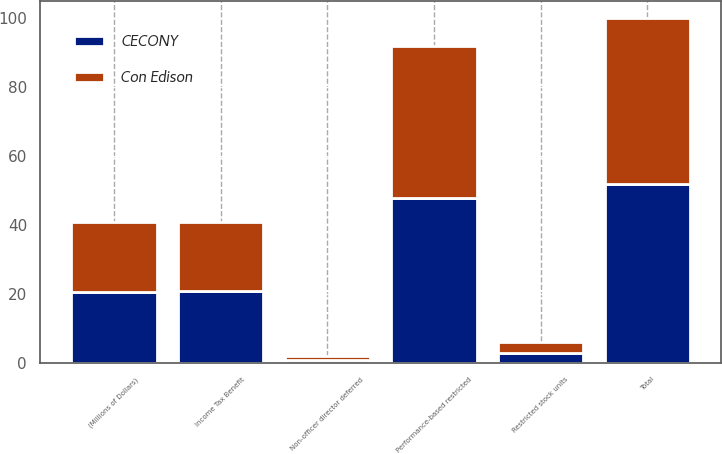<chart> <loc_0><loc_0><loc_500><loc_500><stacked_bar_chart><ecel><fcel>(Millions of Dollars)<fcel>Restricted stock units<fcel>Performance-based restricted<fcel>Non-officer director deferred<fcel>Total<fcel>Income Tax Benefit<nl><fcel>CECONY<fcel>20.5<fcel>3<fcel>48<fcel>1<fcel>52<fcel>21<nl><fcel>Con Edison<fcel>20.5<fcel>3<fcel>44<fcel>1<fcel>48<fcel>20<nl></chart> 